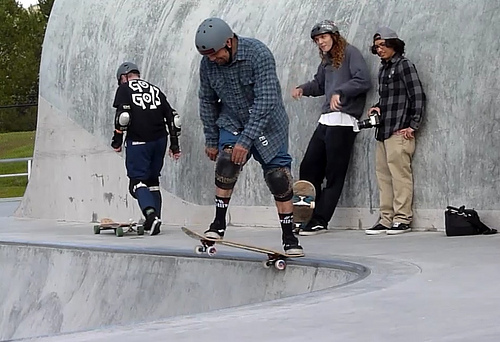Can you describe the attire of the participants? Certainly. The individuals in the image are dressed in casual, sporty gear suitable for skateboarding. The foremost figure is wearing a plaid shirt, jeans, and knee pads. Safety gear, such as helmets and pads, is clearly a priority for these skaters. Is safety gear important for this activity? Absolutely, safety gear is crucial for skateboarding to protect against injuries. It's great to see participants wearing helmets, knee pads, and elbow pads, which indicates they are practicing responsible skating. 